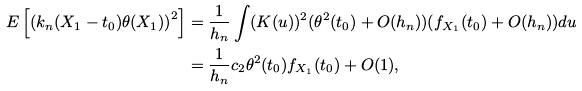Convert formula to latex. <formula><loc_0><loc_0><loc_500><loc_500>E \left [ \left ( k _ { n } ( X _ { 1 } - t _ { 0 } ) \theta ( X _ { 1 } ) \right ) ^ { 2 } \right ] & = \frac { 1 } { h _ { n } } \int ( K ( u ) ) ^ { 2 } ( \theta ^ { 2 } ( t _ { 0 } ) + O ( h _ { n } ) ) ( f _ { X _ { 1 } } ( t _ { 0 } ) + O ( h _ { n } ) ) d u \\ & = \frac { 1 } { h _ { n } } c _ { 2 } \theta ^ { 2 } ( t _ { 0 } ) f _ { X _ { 1 } } ( t _ { 0 } ) + O ( 1 ) ,</formula> 